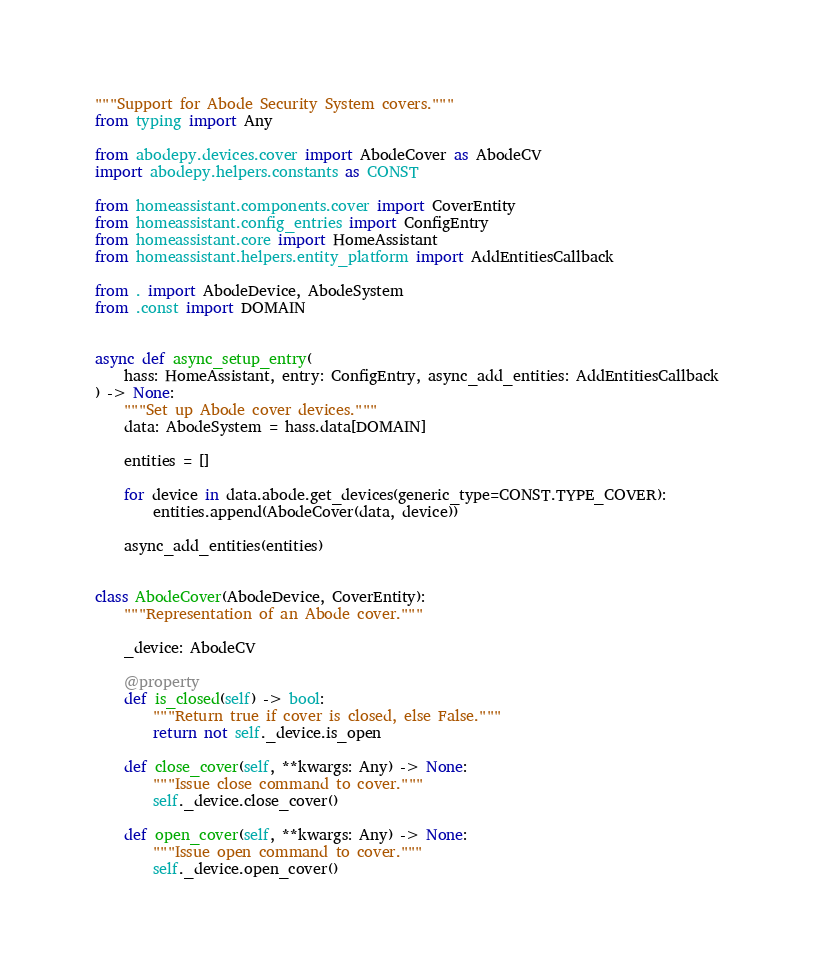<code> <loc_0><loc_0><loc_500><loc_500><_Python_>"""Support for Abode Security System covers."""
from typing import Any

from abodepy.devices.cover import AbodeCover as AbodeCV
import abodepy.helpers.constants as CONST

from homeassistant.components.cover import CoverEntity
from homeassistant.config_entries import ConfigEntry
from homeassistant.core import HomeAssistant
from homeassistant.helpers.entity_platform import AddEntitiesCallback

from . import AbodeDevice, AbodeSystem
from .const import DOMAIN


async def async_setup_entry(
    hass: HomeAssistant, entry: ConfigEntry, async_add_entities: AddEntitiesCallback
) -> None:
    """Set up Abode cover devices."""
    data: AbodeSystem = hass.data[DOMAIN]

    entities = []

    for device in data.abode.get_devices(generic_type=CONST.TYPE_COVER):
        entities.append(AbodeCover(data, device))

    async_add_entities(entities)


class AbodeCover(AbodeDevice, CoverEntity):
    """Representation of an Abode cover."""

    _device: AbodeCV

    @property
    def is_closed(self) -> bool:
        """Return true if cover is closed, else False."""
        return not self._device.is_open

    def close_cover(self, **kwargs: Any) -> None:
        """Issue close command to cover."""
        self._device.close_cover()

    def open_cover(self, **kwargs: Any) -> None:
        """Issue open command to cover."""
        self._device.open_cover()
</code> 